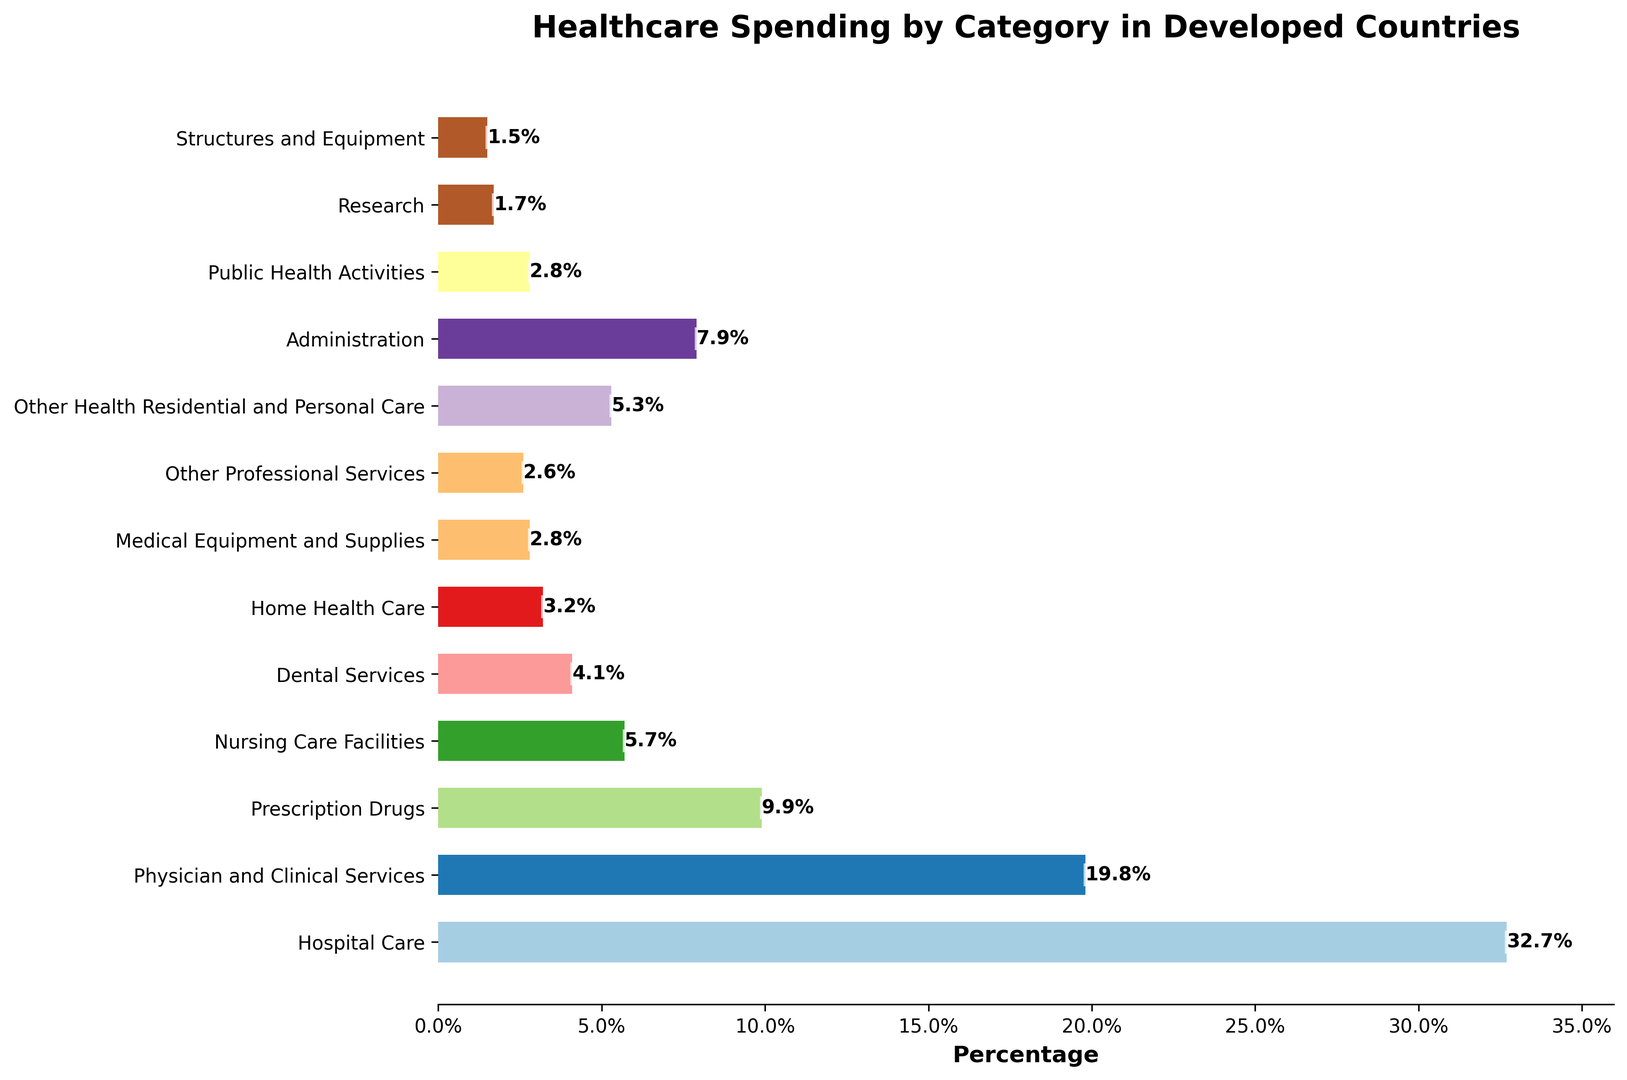Which category accounts for the highest percentage of healthcare spending? Identify the bar with the greatest length representing the highest percentage and read its label.
Answer: Hospital Care What's the difference in spending percentage between Hospital Care and Physician and Clinical Services? Subtract the percentage of Physician and Clinical Services from the percentage of Hospital Care (32.7 - 19.8).
Answer: 12.9% What is the combined spending percentage of Nursing Care Facilities and Home Health Care? Add the percentages of Nursing Care Facilities and Home Health Care (5.7 + 3.2).
Answer: 8.9% Which category has a higher spending percentage: Administration or Nursing Care Facilities? Compare the percentages of Administration (7.9%) and Nursing Care Facilities (5.7%), and identify which is higher.
Answer: Administration What is the average spending percentage of the five smallest categories? Sum the percentages of the five smallest categories (Research 1.7%, Structures and Equipment 1.5%, Other Professional Services 2.6%, Public Health Activities 2.8%, Medical Equipment and Supplies 2.8%) and divide by 5 ((1.7 + 1.5 + 2.6 + 2.8 + 2.8) / 5).
Answer: 2.28% How does the percentage of spending on Prescription Drugs compare to Dental Services? Identify the percentages for Prescription Drugs (9.9%) and Dental Services (4.1%), and determine the difference (9.9 - 4.1).
Answer: 5.8% Which spending category is represented by the fourth bar from the top? Count down the bars from the top and read the label of the fourth bar.
Answer: Prescription Drugs What is the ratio of spending on Hospital Care to Public Health Activities? Divide the percentage of Hospital Care by the percentage of Public Health Activities (32.7 / 2.8).
Answer: 11.68:1 Looking at visual attributes, which bar has the smallest length? Identify the bar with the shortest length and read its label.
Answer: Structures and Equipment 